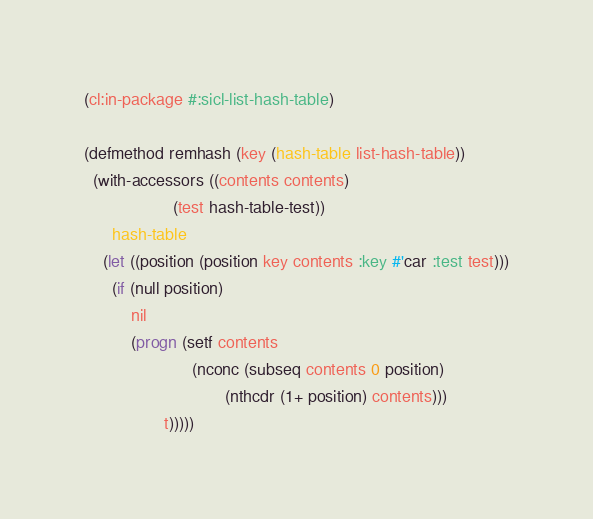Convert code to text. <code><loc_0><loc_0><loc_500><loc_500><_Lisp_>(cl:in-package #:sicl-list-hash-table)

(defmethod remhash (key (hash-table list-hash-table))
  (with-accessors ((contents contents)
                   (test hash-table-test))
      hash-table
    (let ((position (position key contents :key #'car :test test)))
      (if (null position)
          nil
          (progn (setf contents
                       (nconc (subseq contents 0 position)
                              (nthcdr (1+ position) contents)))
                 t)))))
</code> 